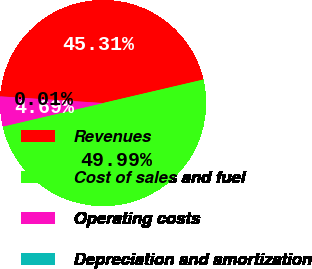Convert chart. <chart><loc_0><loc_0><loc_500><loc_500><pie_chart><fcel>Revenues<fcel>Cost of sales and fuel<fcel>Operating costs<fcel>Depreciation and amortization<nl><fcel>45.31%<fcel>49.99%<fcel>4.69%<fcel>0.01%<nl></chart> 